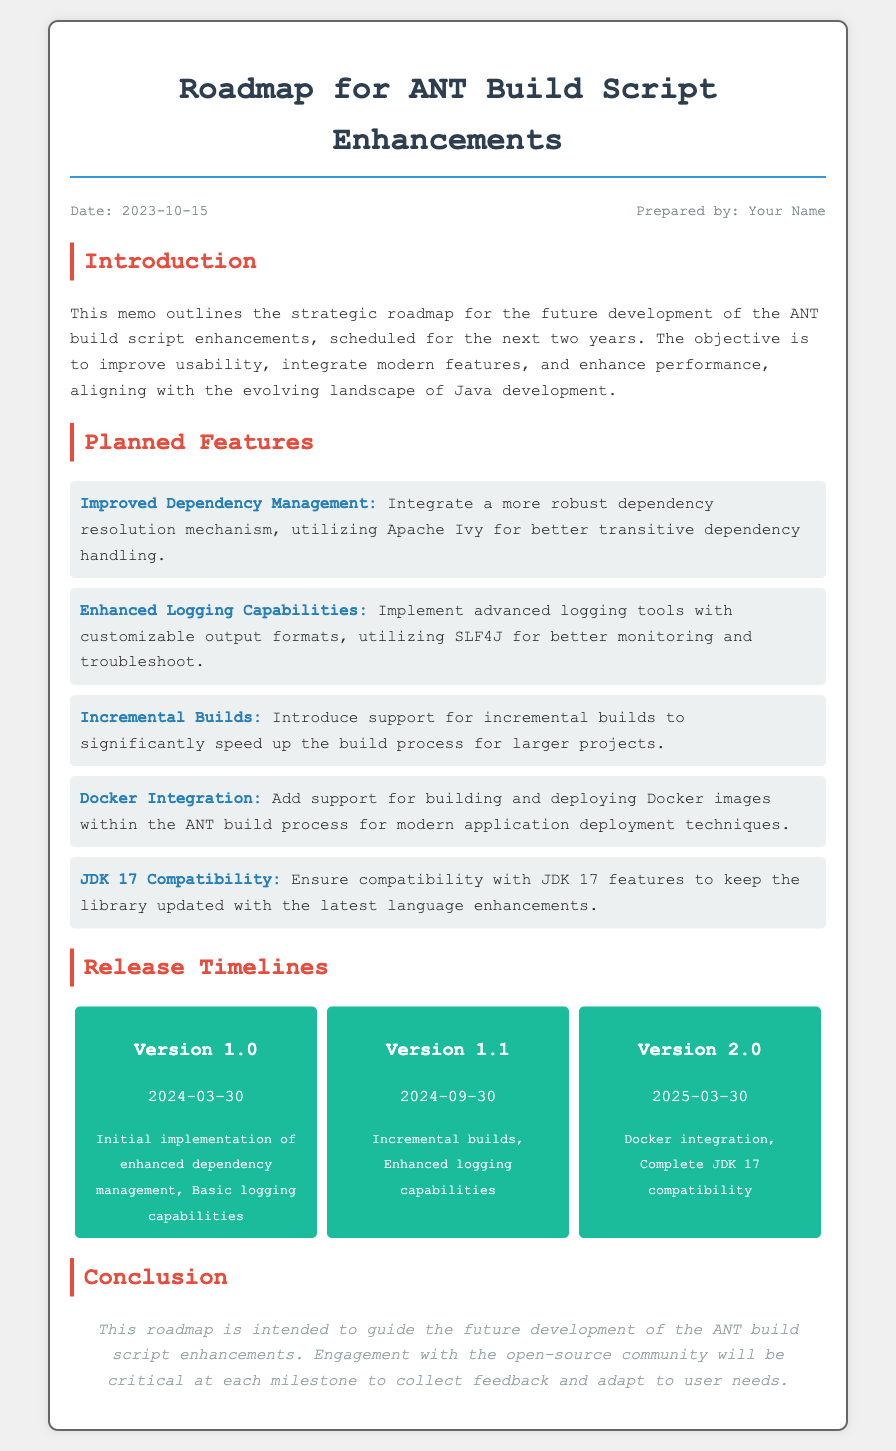What is the date of the memo? The memo date is explicitly stated, which is 2023-10-15.
Answer: 2023-10-15 Who prepared the memo? The memo includes a "Prepared by" section that indicates the author, which is "Your Name."
Answer: Your Name What feature improves dependency resolution? The planned feature for better dependency resolution is noted as "Improved Dependency Management."
Answer: Improved Dependency Management What is the release date for Version 1.1? The document specifies that Version 1.1 will be released on 2024-09-30.
Answer: 2024-09-30 What version introduces Docker integration? The document states that Docker Integration will be included in Version 2.0.
Answer: Version 2.0 Which logging framework is mentioned? The memo mentions implementing logging tools utilizing SLF4J.
Answer: SLF4J How many planned features are listed? The document enumerates a total of five planned features.
Answer: Five What is the main purpose of this roadmap? The roadmap's objective is to improve usability and integrate modern features in the ANT build script enhancements.
Answer: Improve usability and integrate modern features What does the conclusion emphasize? The conclusion highlights the importance of engagement with the open-source community at each milestone.
Answer: Engagement with the open-source community 